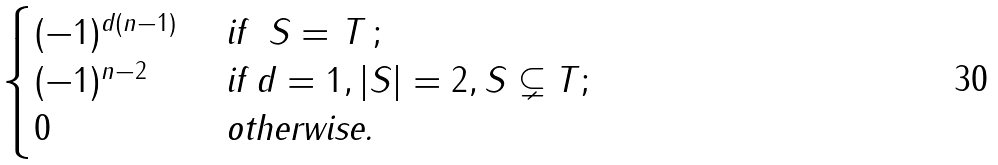<formula> <loc_0><loc_0><loc_500><loc_500>\begin{cases} ( - 1 ) ^ { d ( n - 1 ) } & \text { if } $ S = T $ ; \\ ( - 1 ) ^ { n - 2 } & \text { if $d=1,|S|=2,S\subsetneq T$} ; \\ 0 & \text { otherwise.} \end{cases}</formula> 